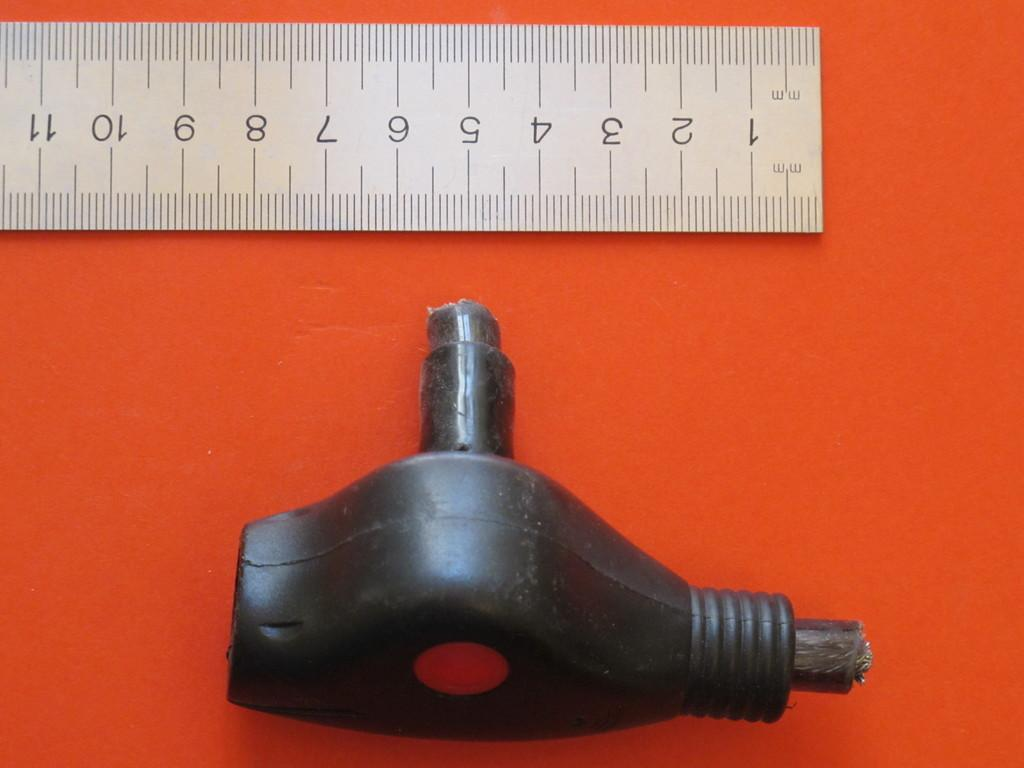<image>
Render a clear and concise summary of the photo. A mechanical object that is shown to be approximately 8 centimeters in length 